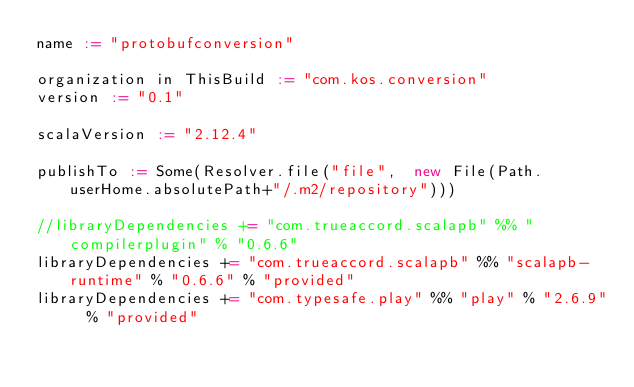<code> <loc_0><loc_0><loc_500><loc_500><_Scala_>name := "protobufconversion"

organization in ThisBuild := "com.kos.conversion"
version := "0.1"

scalaVersion := "2.12.4"

publishTo := Some(Resolver.file("file",  new File(Path.userHome.absolutePath+"/.m2/repository")))

//libraryDependencies += "com.trueaccord.scalapb" %% "compilerplugin" % "0.6.6"
libraryDependencies += "com.trueaccord.scalapb" %% "scalapb-runtime" % "0.6.6" % "provided"
libraryDependencies += "com.typesafe.play" %% "play" % "2.6.9"  % "provided"</code> 